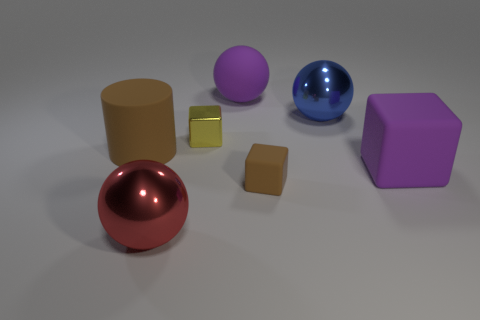There is a block that is behind the big brown rubber cylinder; is it the same color as the tiny cube that is in front of the big brown matte cylinder?
Your response must be concise. No. Are there the same number of large blue objects in front of the big blue metallic ball and large matte cylinders?
Make the answer very short. No. There is a blue ball; what number of big brown rubber objects are behind it?
Your answer should be very brief. 0. What is the size of the purple sphere?
Your answer should be very brief. Large. What color is the tiny block that is made of the same material as the big cylinder?
Provide a succinct answer. Brown. What number of cyan metallic spheres are the same size as the red metallic ball?
Provide a short and direct response. 0. Do the yellow block on the left side of the brown block and the purple cube have the same material?
Give a very brief answer. No. Is the number of metallic things to the left of the blue thing less than the number of tiny brown rubber blocks?
Make the answer very short. No. There is a large shiny thing that is in front of the brown cylinder; what shape is it?
Give a very brief answer. Sphere. What is the shape of the red thing that is the same size as the brown matte cylinder?
Provide a short and direct response. Sphere. 